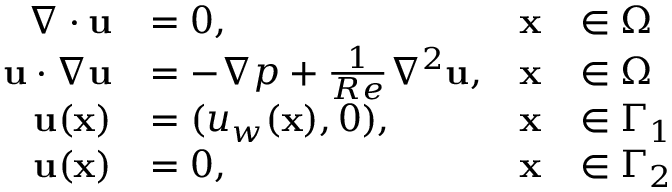<formula> <loc_0><loc_0><loc_500><loc_500>\begin{array} { r l r l } { \nabla \cdot { u } } & { = 0 , } & { x } & { \in \Omega } \\ { { u } \cdot \nabla { u } } & { = - \nabla p + \frac { 1 } { R e } { \nabla ^ { 2 } } { u } , } & { x } & { \in \Omega } \\ { u ( x ) } & { = ( u _ { w } ( x ) , 0 ) , } & { x } & { \in \Gamma _ { 1 } } \\ { u ( x ) } & { = 0 , } & { x } & { \in \Gamma _ { 2 } } \end{array}</formula> 